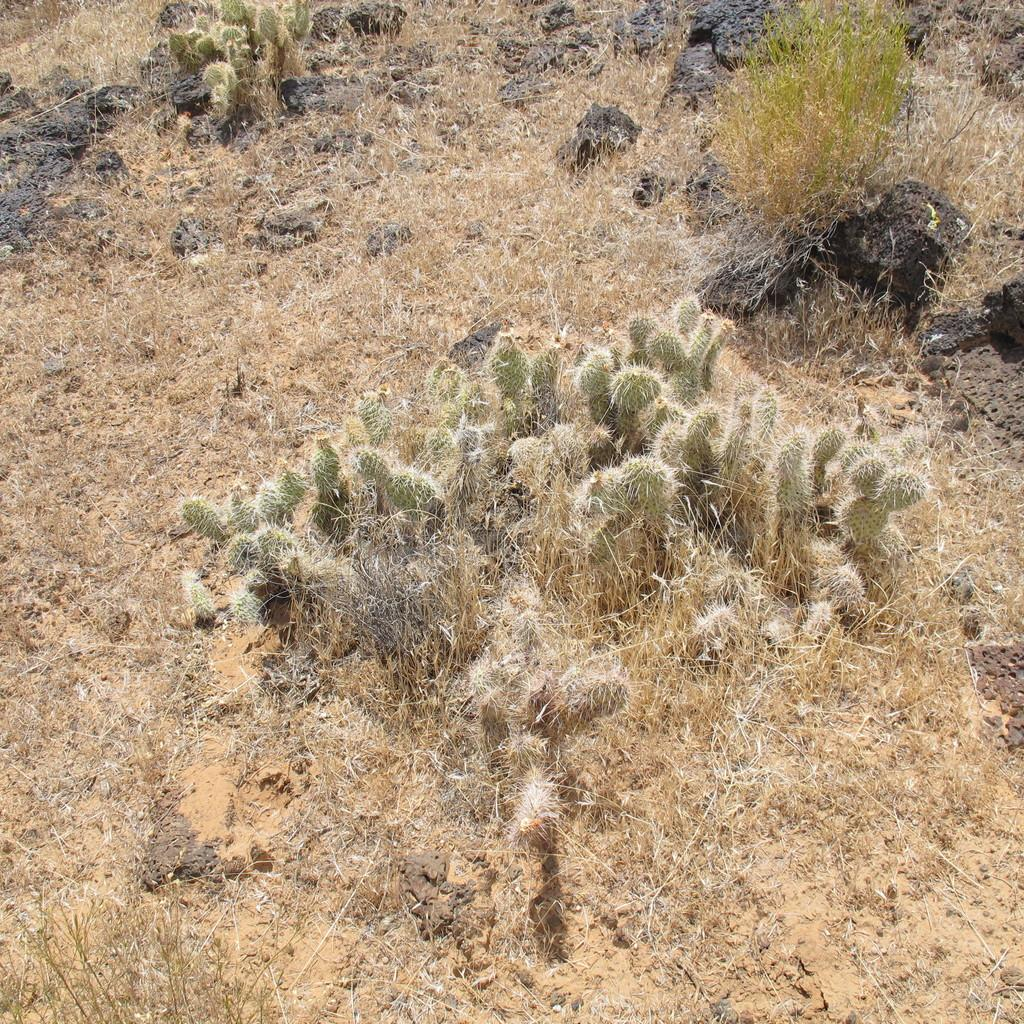What type of plants are in the image? There are cactus plants in the image. Where are the cactus plants located? The cactus plants are on a grassy land. How many goats can be seen grazing near the cactus plants in the image? There are no goats present in the image; it only features cactus plants on a grassy land. What type of bird is perched on the cactus plant in the image? There are no birds, such as owls, present in the image; it only features cactus plants on a grassy land. 